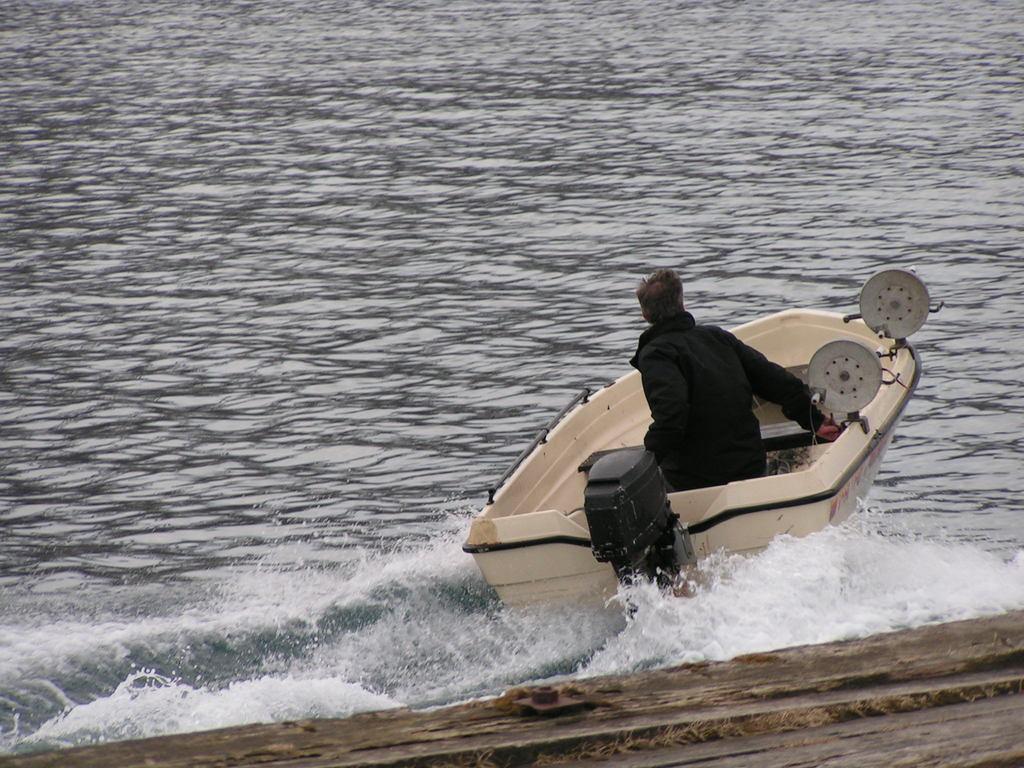Could you give a brief overview of what you see in this image? At the bottom of the image we can see water, above the water a person is riding a boat. 